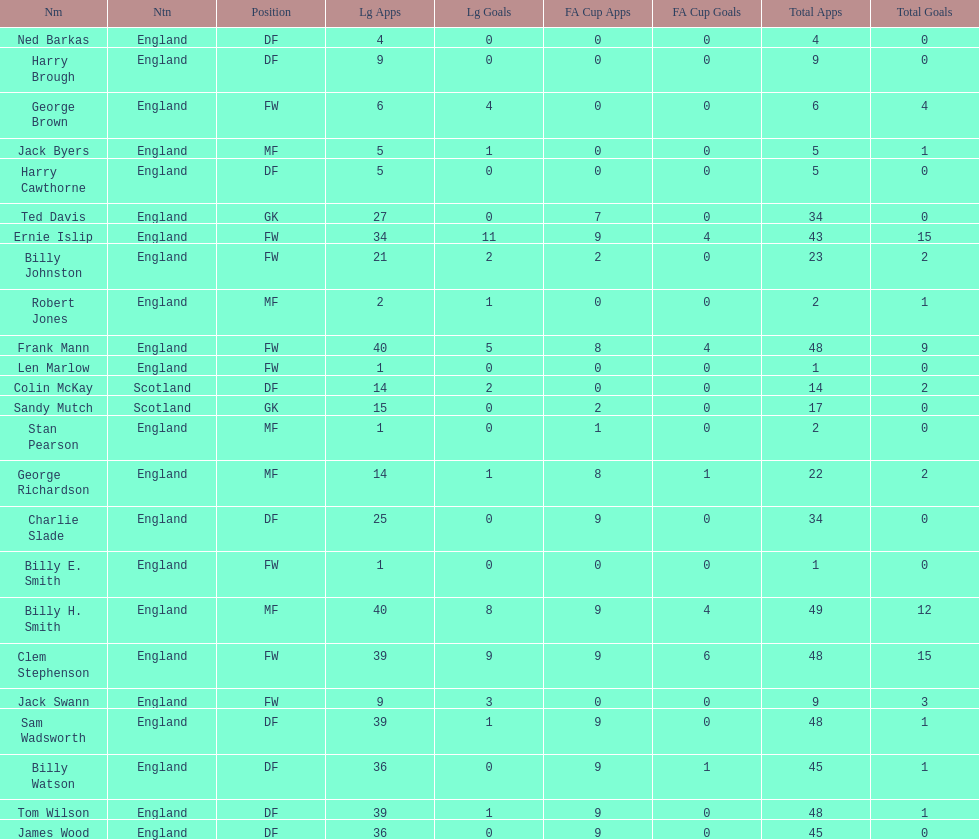What is the first name listed? Ned Barkas. 